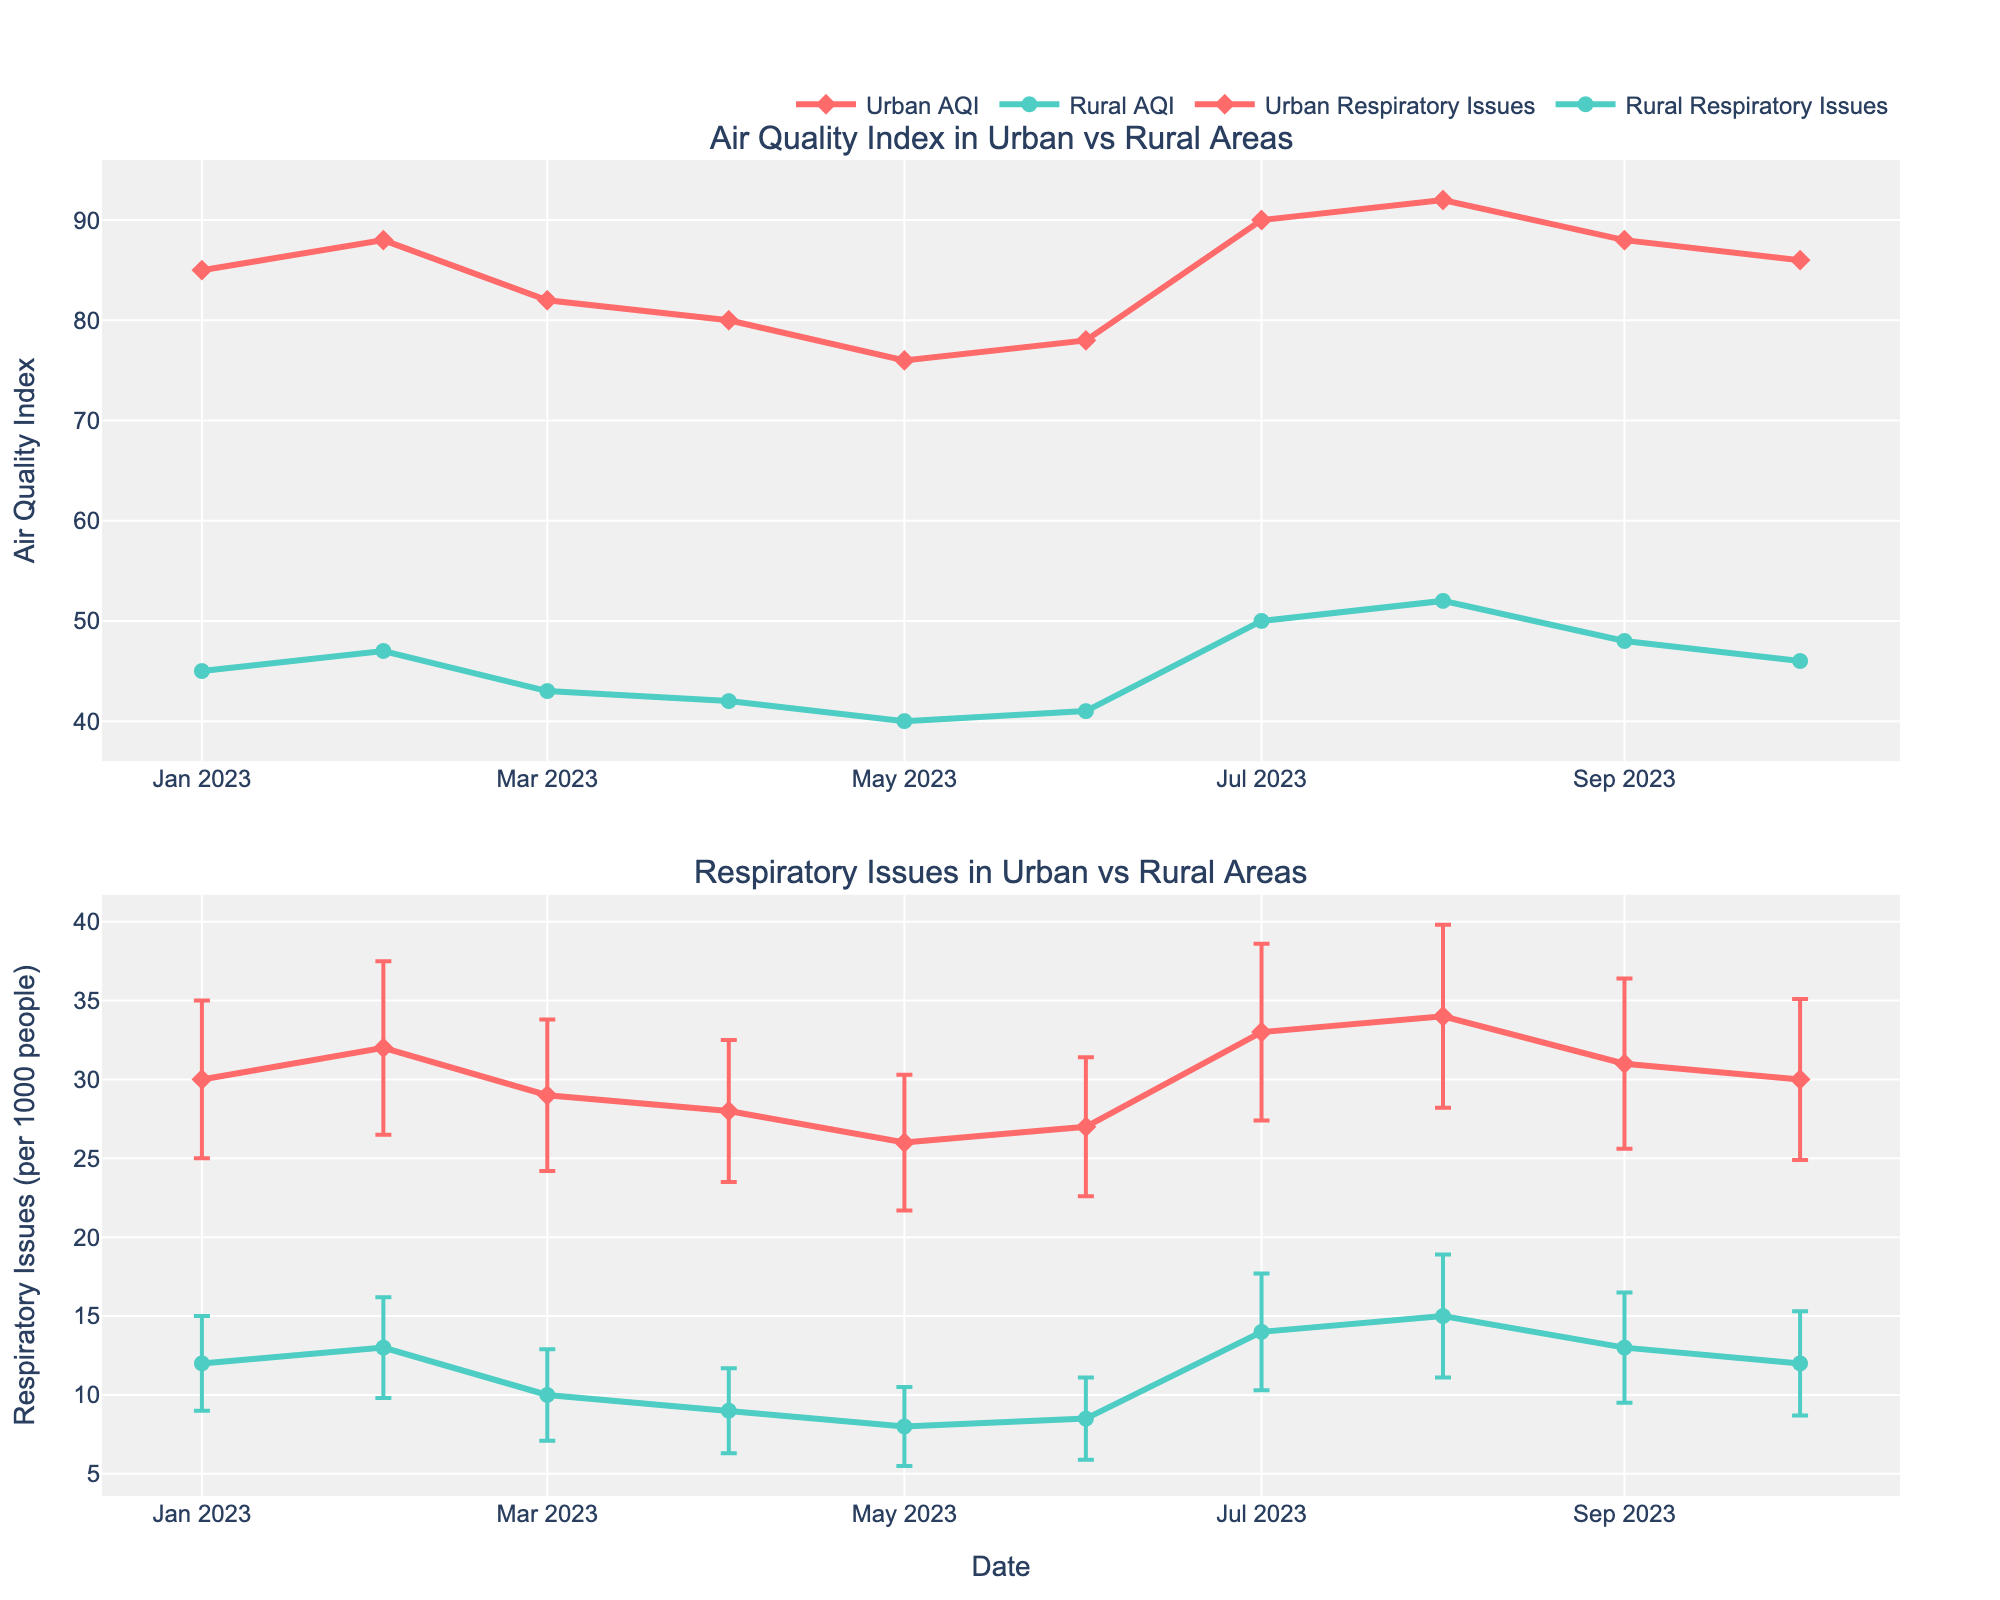What is the title of the top subplot? The title is visible at the top of the plot, and it labels the data being shown in the first subplot.
Answer: Air Quality Index in Urban vs Rural Areas How many urban and rural areas are compared in the figure? By counting the different dates and corresponding cities labeled in the plot, we can determine the variety of locations compared.
Answer: 6 urban and 6 rural areas What is the trend of the Air Quality Index in urban areas from January to October 2023? Looking at the line for Urban AQI in the top subplot, we can see how the values change over time.
Answer: Generally increasing with peaks and slight declines Which location has the highest Air Quality Index in August 2023? Locate August 2023 on the x-axis of the top subplot and identify the highest AQI point among urban and rural lines.
Answer: Houston (Urban) What is the standard deviation of respiratory issues in Conroe in July 2023? Refer to the lower subplot where error bars indicate the standard deviation, find Conroe's data in July 2023.
Answer: 3.7 Compare the average respiratory issues in urban and rural areas in January 2023. Locate January 2023 data points for both urban and rural areas in the lower subplot and compare their mean values.
Answer: 30 for Urban and 12 for Rural Which month shows the largest difference in mean respiratory issues between urban and rural areas? Visually compare the vertical distances between the urban and rural points across all months in the lower subplot.
Answer: August 2023 Is there a correlation between Air Quality Index and respiratory issues across the urban data? Observe the pattern in the scatter points and the rise/fall trends in both subplots for urban data to determine the relationship.
Answer: Yes, higher AQI correlates with higher respiratory issues What is the lowest Air Quality Index value recorded for rural areas and in which month does it occur? Check the minimum point on the rural line (green) in the top subplot and note the corresponding month.
Answer: 40 in May 2023 How do error bars for respiratory issues compare between urban and rural areas in April 2023? Look at the error bars associated with the points in April in the lower subplot to compare their lengths.
Answer: Urban error bars are larger than rural ones 